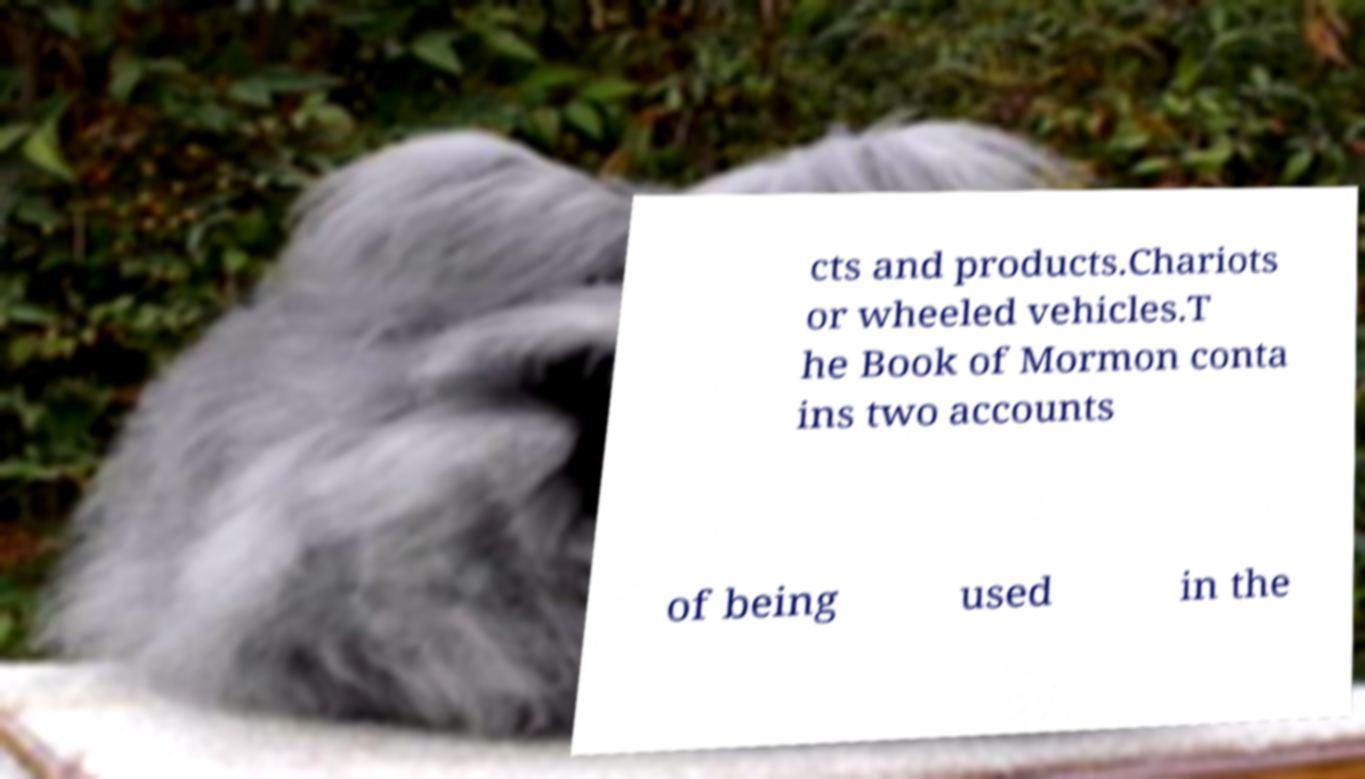There's text embedded in this image that I need extracted. Can you transcribe it verbatim? cts and products.Chariots or wheeled vehicles.T he Book of Mormon conta ins two accounts of being used in the 